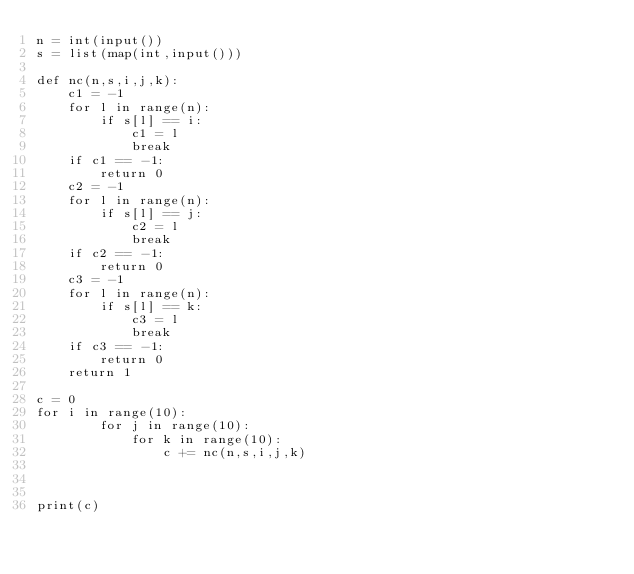Convert code to text. <code><loc_0><loc_0><loc_500><loc_500><_Python_>n = int(input())
s = list(map(int,input()))

def nc(n,s,i,j,k):
    c1 = -1
    for l in range(n):
        if s[l] == i:
            c1 = l
            break
    if c1 == -1:
        return 0
    c2 = -1
    for l in range(n):
        if s[l] == j:
            c2 = l
            break
    if c2 == -1:
        return 0
    c3 = -1
    for l in range(n):
        if s[l] == k:
            c3 = l
            break
    if c3 == -1:
        return 0
    return 1

c = 0
for i in range(10):
        for j in range(10):
            for k in range(10):
                c += nc(n,s,i,j,k)



print(c)
</code> 